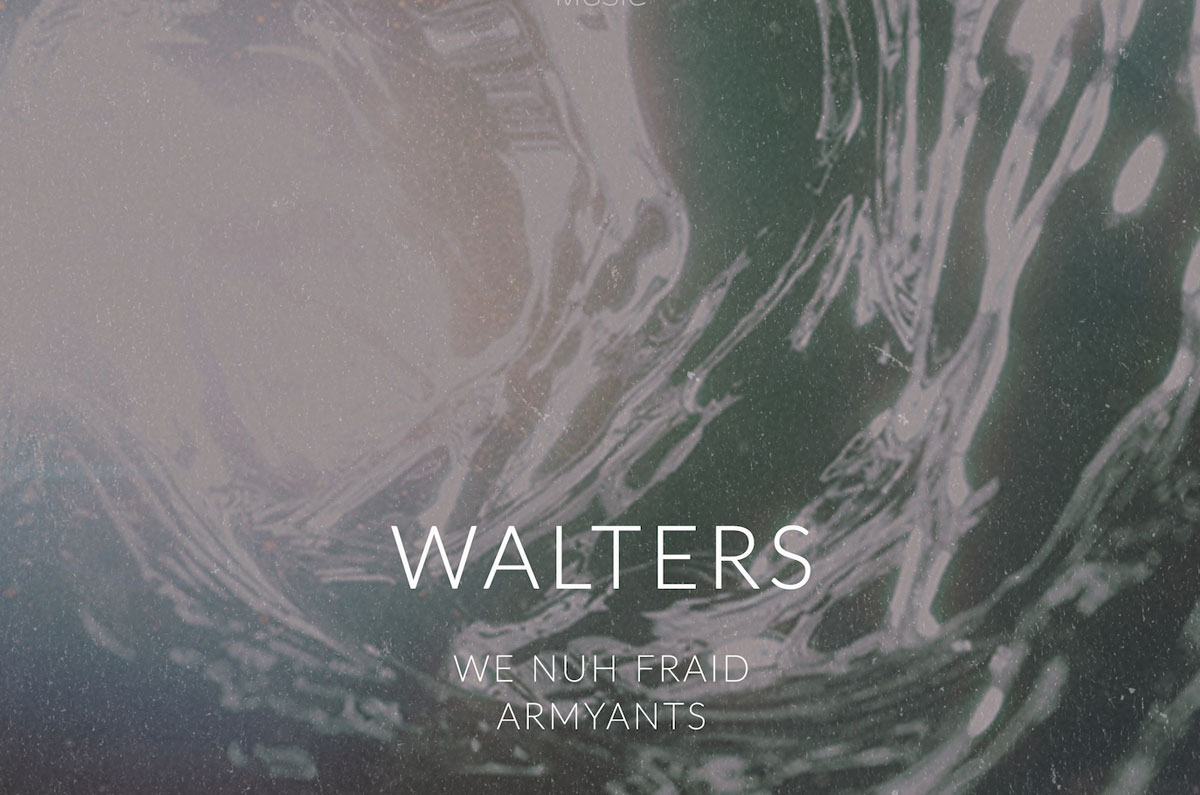If you had to create a narrative based solely on the text and background in the image, what story would you tell? The image seems to tell the story of 'WALTERS,' a resilient and fearless leader symbolized by the phrase 'WE NUH FRAID.' This leader has a background rooted in a complex, perhaps turbulent, environment depicted by the marbled, swirling background. 'ARMYANTS' might refer to a loyal group or following, suggesting that Walters and his allies navigate through challenges with courage and unity, much like army ants collectively overcome obstacles. This narrative speaks to themes of leadership, bravery, and solidarity in the face of adversity. Let’s explore something wild. What if 'WALTERS' was actually a planet in a science fiction universe? Describe its inhabitants and their culture. In a distant corner of the universe lies the planet Walters, a realm of breathtaking, ever-changing landscapes mirroring the marbled patterns in the image. The inhabitants of Walters, known as the Walteri, are a resilient and adaptable species. Resembling humanoids with intricately patterned skin that shifts colors with their emotions, they have evolved to thrive in their planet's volatile environment. The Walteri culture is built around principles of unity and fearlessness, as highlighted by their motto, 'WE NUH FRAID.' They follow the teachings of an ancient order known as the ArmyAnts, who emphasize collective strength and harmonious living. The Walteri society is a blend of advanced technology and deep-rooted traditions, where art and science coexist seamlessly to navigate the planet’s ever-changing challenges. 